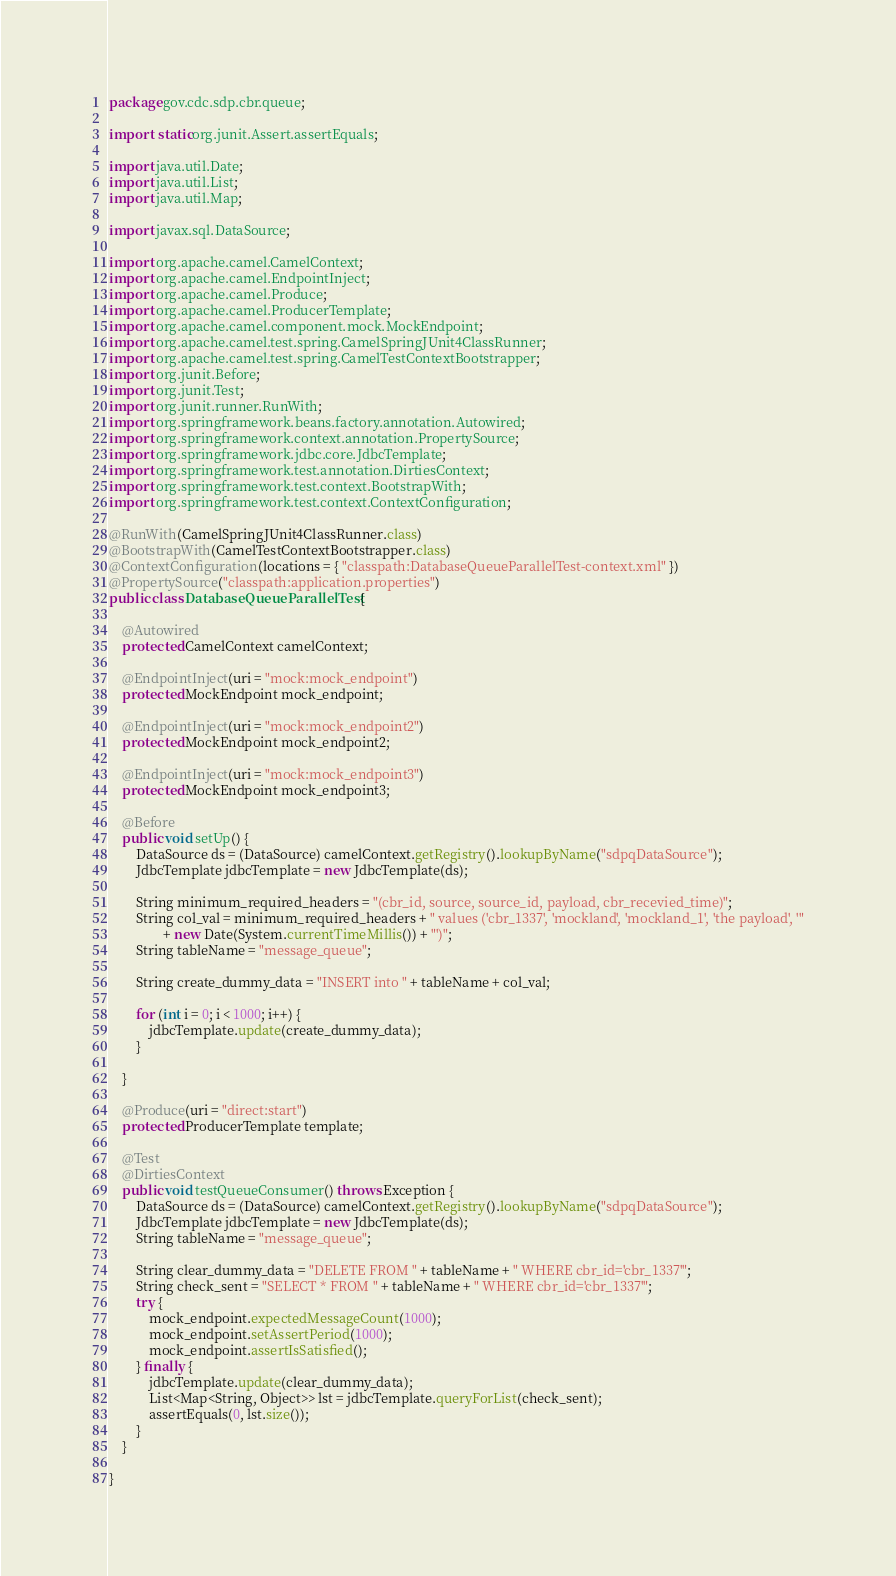Convert code to text. <code><loc_0><loc_0><loc_500><loc_500><_Java_>package gov.cdc.sdp.cbr.queue;

import static org.junit.Assert.assertEquals;

import java.util.Date;
import java.util.List;
import java.util.Map;

import javax.sql.DataSource;

import org.apache.camel.CamelContext;
import org.apache.camel.EndpointInject;
import org.apache.camel.Produce;
import org.apache.camel.ProducerTemplate;
import org.apache.camel.component.mock.MockEndpoint;
import org.apache.camel.test.spring.CamelSpringJUnit4ClassRunner;
import org.apache.camel.test.spring.CamelTestContextBootstrapper;
import org.junit.Before;
import org.junit.Test;
import org.junit.runner.RunWith;
import org.springframework.beans.factory.annotation.Autowired;
import org.springframework.context.annotation.PropertySource;
import org.springframework.jdbc.core.JdbcTemplate;
import org.springframework.test.annotation.DirtiesContext;
import org.springframework.test.context.BootstrapWith;
import org.springframework.test.context.ContextConfiguration;

@RunWith(CamelSpringJUnit4ClassRunner.class)
@BootstrapWith(CamelTestContextBootstrapper.class)
@ContextConfiguration(locations = { "classpath:DatabaseQueueParallelTest-context.xml" })
@PropertySource("classpath:application.properties")
public class DatabaseQueueParallelTest {

    @Autowired
    protected CamelContext camelContext;

    @EndpointInject(uri = "mock:mock_endpoint")
    protected MockEndpoint mock_endpoint;

    @EndpointInject(uri = "mock:mock_endpoint2")
    protected MockEndpoint mock_endpoint2;

    @EndpointInject(uri = "mock:mock_endpoint3")
    protected MockEndpoint mock_endpoint3;

    @Before
    public void setUp() {
        DataSource ds = (DataSource) camelContext.getRegistry().lookupByName("sdpqDataSource");
        JdbcTemplate jdbcTemplate = new JdbcTemplate(ds);

        String minimum_required_headers = "(cbr_id, source, source_id, payload, cbr_recevied_time)";
        String col_val = minimum_required_headers + " values ('cbr_1337', 'mockland', 'mockland_1', 'the payload', '"
                + new Date(System.currentTimeMillis()) + "')";
        String tableName = "message_queue";

        String create_dummy_data = "INSERT into " + tableName + col_val;

        for (int i = 0; i < 1000; i++) {
            jdbcTemplate.update(create_dummy_data);
        }

    }

    @Produce(uri = "direct:start")
    protected ProducerTemplate template;

    @Test
    @DirtiesContext
    public void testQueueConsumer() throws Exception {
        DataSource ds = (DataSource) camelContext.getRegistry().lookupByName("sdpqDataSource");
        JdbcTemplate jdbcTemplate = new JdbcTemplate(ds);
        String tableName = "message_queue";

        String clear_dummy_data = "DELETE FROM " + tableName + " WHERE cbr_id='cbr_1337'";
        String check_sent = "SELECT * FROM " + tableName + " WHERE cbr_id='cbr_1337'";
        try {
            mock_endpoint.expectedMessageCount(1000);
            mock_endpoint.setAssertPeriod(1000);
            mock_endpoint.assertIsSatisfied();
        } finally {
            jdbcTemplate.update(clear_dummy_data);
            List<Map<String, Object>> lst = jdbcTemplate.queryForList(check_sent);
            assertEquals(0, lst.size());
        }
    }

}
</code> 